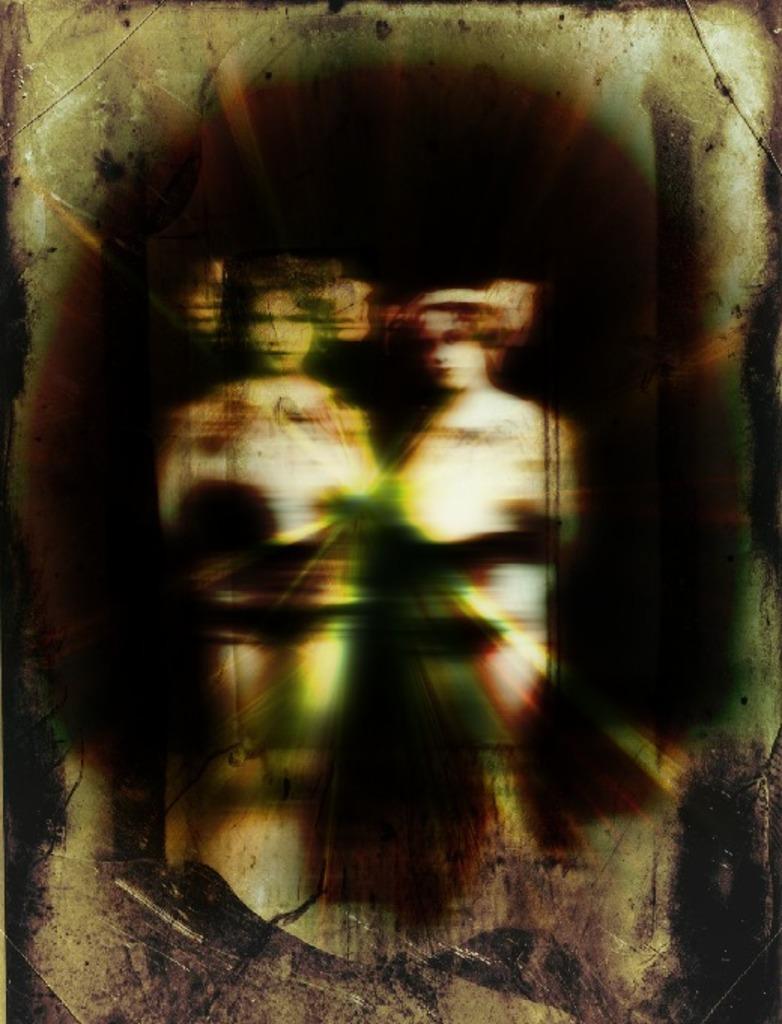In one or two sentences, can you explain what this image depicts? In this image we can see a photo frame with two persons. 